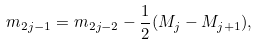<formula> <loc_0><loc_0><loc_500><loc_500>m _ { 2 j - 1 } = m _ { 2 j - 2 } - \frac { 1 } { 2 } ( M _ { j } - M _ { j + 1 } ) ,</formula> 